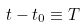<formula> <loc_0><loc_0><loc_500><loc_500>t - t _ { 0 } \equiv T</formula> 